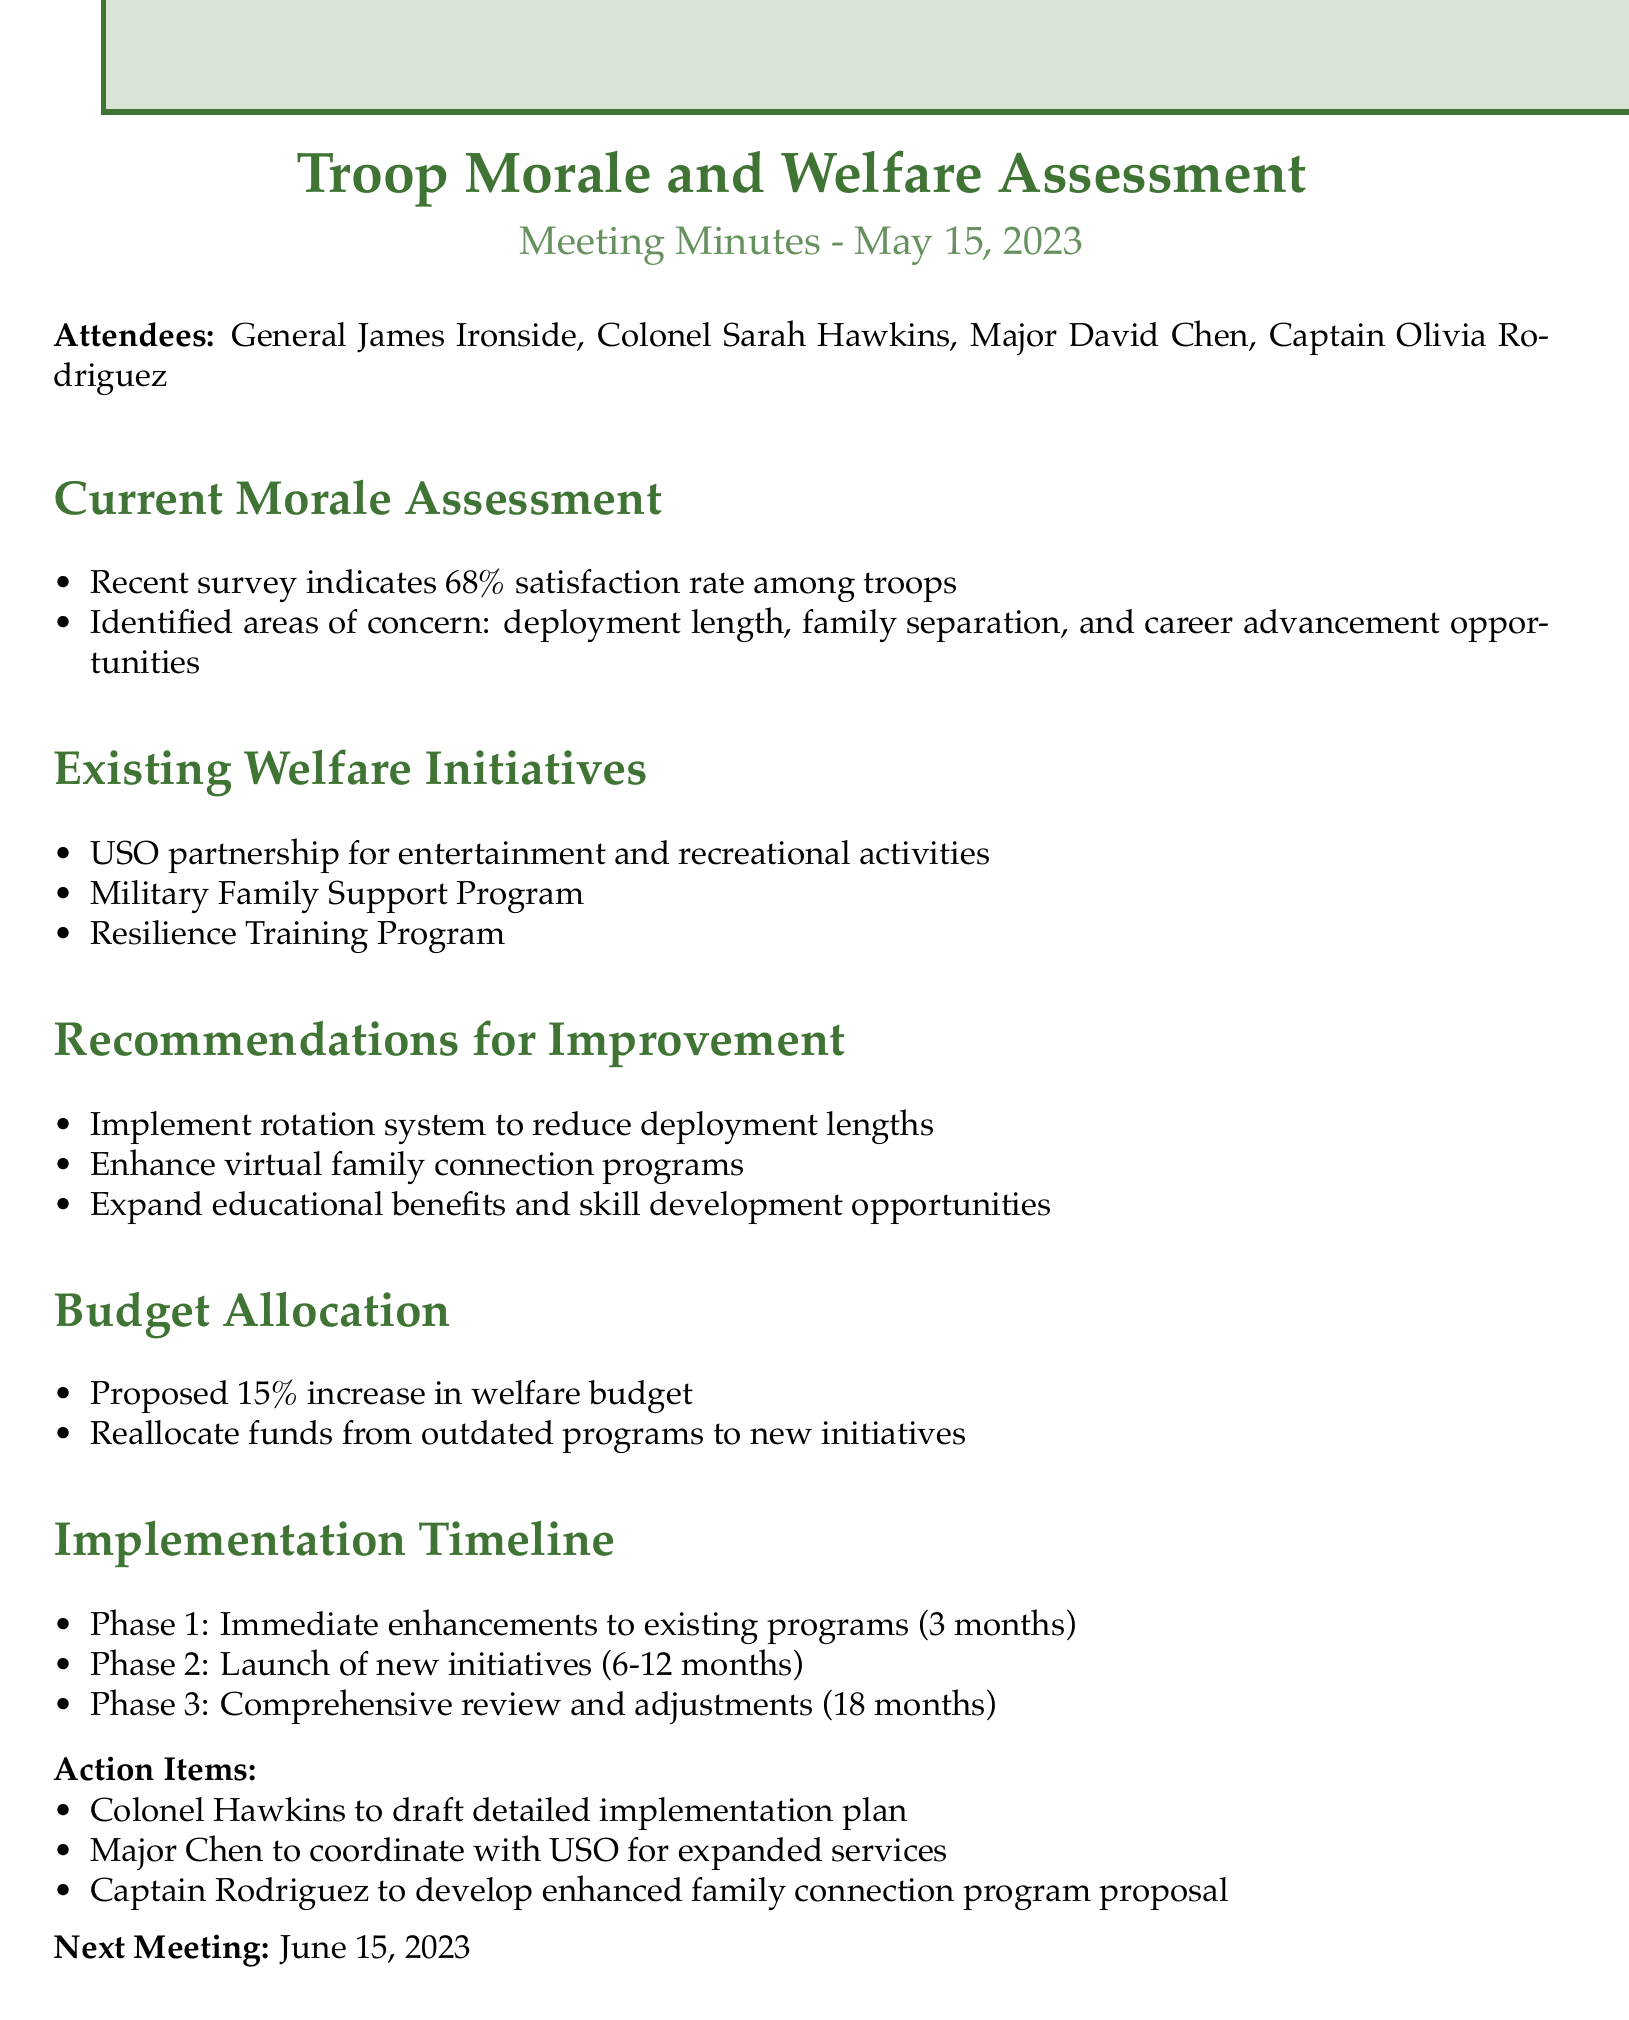What is the satisfaction rate among troops? The document states that the recent survey indicates a satisfaction rate of 68% among troops.
Answer: 68% What are the areas of concern identified in the morale assessment? The document lists deployment length, family separation, and career advancement opportunities as areas of concern.
Answer: Deployment length, family separation, career advancement opportunities What is the proposed increase in the welfare budget? The minutes suggest a proposed 15% increase in the welfare budget.
Answer: 15% Who is responsible for drafting the detailed implementation plan? Colonel Hawkins is assigned to draft the detailed implementation plan according to the action items listed in the minutes.
Answer: Colonel Hawkins What phase involves immediate enhancements to existing programs? The document outlines that Phase 1 focuses on immediate enhancements to existing programs within a 3-month timeline.
Answer: Phase 1 What initiative is proposed to enhance family connections? The minutes mention enhancing virtual family connection programs as part of the recommendations for improvement.
Answer: Enhance virtual family connection programs When is the next meeting scheduled? The next meeting is scheduled for June 15, 2023, as noted at the end of the minutes.
Answer: June 15, 2023 Which officer will coordinate with USO for expanded services? Major Chen is designated to coordinate with USO for expanded services, as stated in the action items.
Answer: Major Chen 